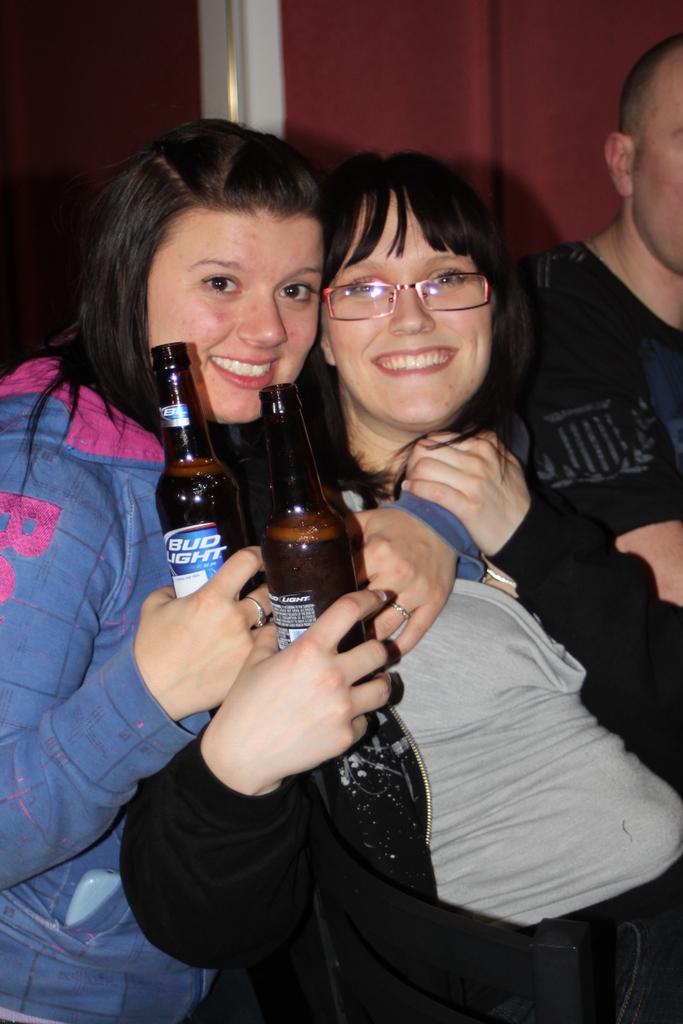Could you give a brief overview of what you see in this image? There are three people in a room. In the center we have a two people. They both are smiling. They both are holding a bottles. 